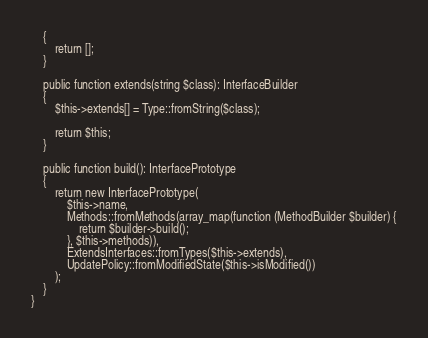<code> <loc_0><loc_0><loc_500><loc_500><_PHP_>    {
        return [];
    }

    public function extends(string $class): InterfaceBuilder
    {
        $this->extends[] = Type::fromString($class);

        return $this;
    }

    public function build(): InterfacePrototype
    {
        return new InterfacePrototype(
            $this->name,
            Methods::fromMethods(array_map(function (MethodBuilder $builder) {
                return $builder->build();
            }, $this->methods)),
            ExtendsInterfaces::fromTypes($this->extends),
            UpdatePolicy::fromModifiedState($this->isModified())
        );
    }
}
</code> 